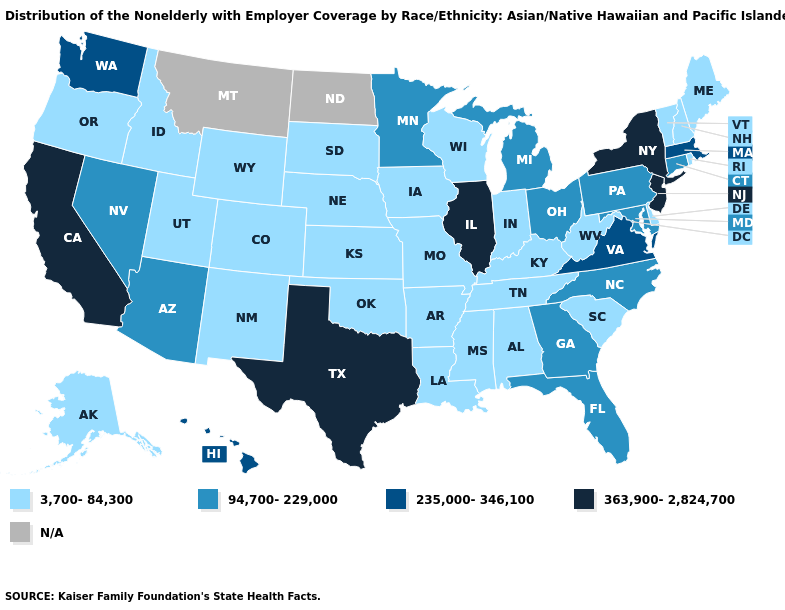What is the value of Tennessee?
Be succinct. 3,700-84,300. What is the value of Rhode Island?
Keep it brief. 3,700-84,300. What is the value of Arkansas?
Write a very short answer. 3,700-84,300. How many symbols are there in the legend?
Answer briefly. 5. Name the states that have a value in the range 363,900-2,824,700?
Give a very brief answer. California, Illinois, New Jersey, New York, Texas. Which states have the lowest value in the USA?
Be succinct. Alabama, Alaska, Arkansas, Colorado, Delaware, Idaho, Indiana, Iowa, Kansas, Kentucky, Louisiana, Maine, Mississippi, Missouri, Nebraska, New Hampshire, New Mexico, Oklahoma, Oregon, Rhode Island, South Carolina, South Dakota, Tennessee, Utah, Vermont, West Virginia, Wisconsin, Wyoming. What is the lowest value in states that border New Jersey?
Concise answer only. 3,700-84,300. What is the lowest value in the MidWest?
Be succinct. 3,700-84,300. Is the legend a continuous bar?
Short answer required. No. What is the value of Indiana?
Write a very short answer. 3,700-84,300. What is the lowest value in states that border Minnesota?
Short answer required. 3,700-84,300. Name the states that have a value in the range 3,700-84,300?
Keep it brief. Alabama, Alaska, Arkansas, Colorado, Delaware, Idaho, Indiana, Iowa, Kansas, Kentucky, Louisiana, Maine, Mississippi, Missouri, Nebraska, New Hampshire, New Mexico, Oklahoma, Oregon, Rhode Island, South Carolina, South Dakota, Tennessee, Utah, Vermont, West Virginia, Wisconsin, Wyoming. What is the highest value in states that border Montana?
Be succinct. 3,700-84,300. Name the states that have a value in the range 363,900-2,824,700?
Short answer required. California, Illinois, New Jersey, New York, Texas. 